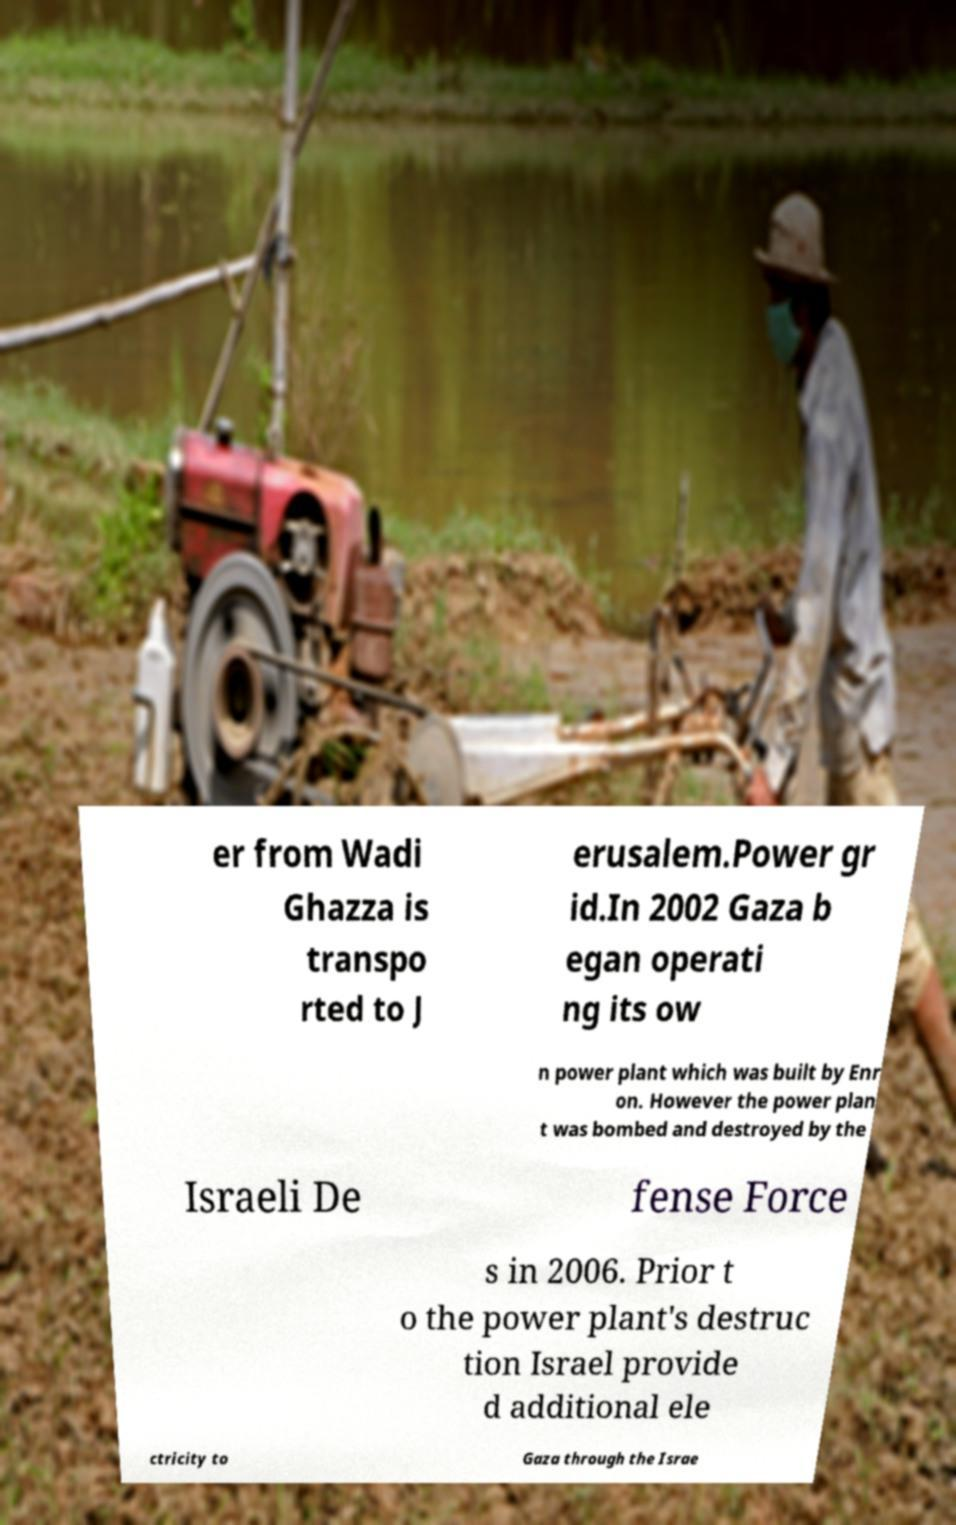Please read and relay the text visible in this image. What does it say? er from Wadi Ghazza is transpo rted to J erusalem.Power gr id.In 2002 Gaza b egan operati ng its ow n power plant which was built by Enr on. However the power plan t was bombed and destroyed by the Israeli De fense Force s in 2006. Prior t o the power plant's destruc tion Israel provide d additional ele ctricity to Gaza through the Israe 